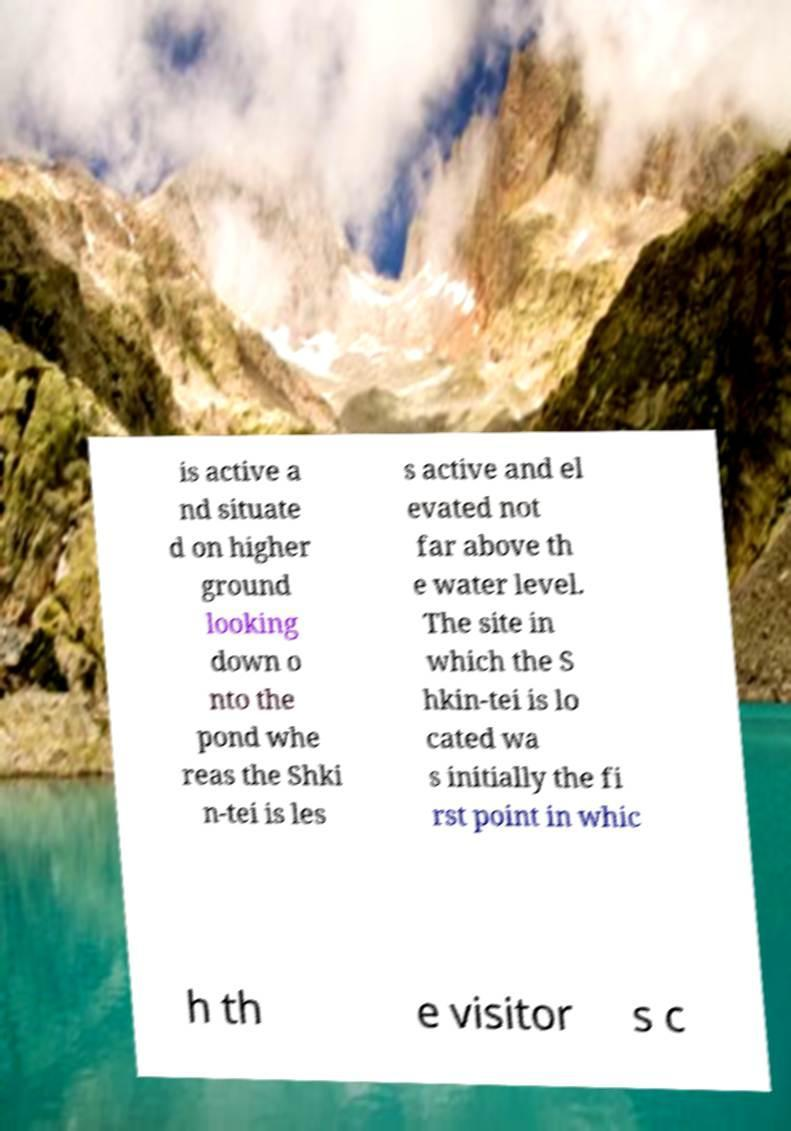For documentation purposes, I need the text within this image transcribed. Could you provide that? is active a nd situate d on higher ground looking down o nto the pond whe reas the Shki n-tei is les s active and el evated not far above th e water level. The site in which the S hkin-tei is lo cated wa s initially the fi rst point in whic h th e visitor s c 